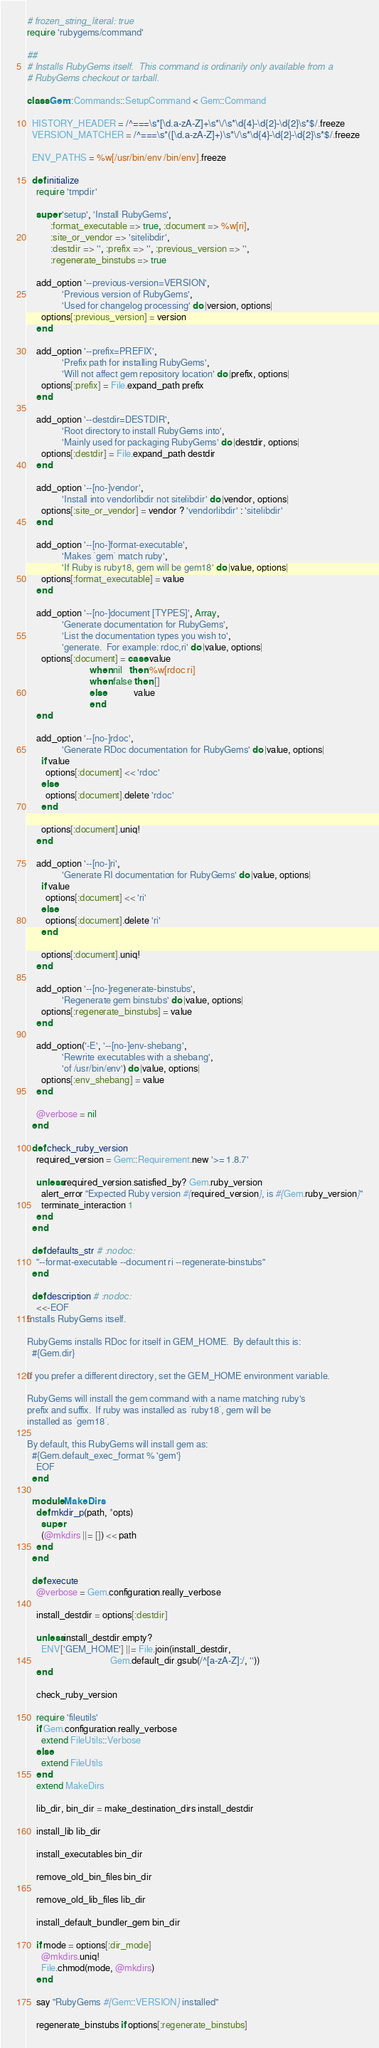<code> <loc_0><loc_0><loc_500><loc_500><_Ruby_># frozen_string_literal: true
require 'rubygems/command'

##
# Installs RubyGems itself.  This command is ordinarily only available from a
# RubyGems checkout or tarball.

class Gem::Commands::SetupCommand < Gem::Command

  HISTORY_HEADER = /^===\s*[\d.a-zA-Z]+\s*\/\s*\d{4}-\d{2}-\d{2}\s*$/.freeze
  VERSION_MATCHER = /^===\s*([\d.a-zA-Z]+)\s*\/\s*\d{4}-\d{2}-\d{2}\s*$/.freeze

  ENV_PATHS = %w[/usr/bin/env /bin/env].freeze

  def initialize
    require 'tmpdir'

    super 'setup', 'Install RubyGems',
          :format_executable => true, :document => %w[ri],
          :site_or_vendor => 'sitelibdir',
          :destdir => '', :prefix => '', :previous_version => '',
          :regenerate_binstubs => true

    add_option '--previous-version=VERSION',
               'Previous version of RubyGems',
               'Used for changelog processing' do |version, options|
      options[:previous_version] = version
    end

    add_option '--prefix=PREFIX',
               'Prefix path for installing RubyGems',
               'Will not affect gem repository location' do |prefix, options|
      options[:prefix] = File.expand_path prefix
    end

    add_option '--destdir=DESTDIR',
               'Root directory to install RubyGems into',
               'Mainly used for packaging RubyGems' do |destdir, options|
      options[:destdir] = File.expand_path destdir
    end

    add_option '--[no-]vendor',
               'Install into vendorlibdir not sitelibdir' do |vendor, options|
      options[:site_or_vendor] = vendor ? 'vendorlibdir' : 'sitelibdir'
    end

    add_option '--[no-]format-executable',
               'Makes `gem` match ruby',
               'If Ruby is ruby18, gem will be gem18' do |value, options|
      options[:format_executable] = value
    end

    add_option '--[no-]document [TYPES]', Array,
               'Generate documentation for RubyGems',
               'List the documentation types you wish to',
               'generate.  For example: rdoc,ri' do |value, options|
      options[:document] = case value
                           when nil   then %w[rdoc ri]
                           when false then []
                           else            value
                           end
    end

    add_option '--[no-]rdoc',
               'Generate RDoc documentation for RubyGems' do |value, options|
      if value
        options[:document] << 'rdoc'
      else
        options[:document].delete 'rdoc'
      end

      options[:document].uniq!
    end

    add_option '--[no-]ri',
               'Generate RI documentation for RubyGems' do |value, options|
      if value
        options[:document] << 'ri'
      else
        options[:document].delete 'ri'
      end

      options[:document].uniq!
    end

    add_option '--[no-]regenerate-binstubs',
               'Regenerate gem binstubs' do |value, options|
      options[:regenerate_binstubs] = value
    end

    add_option('-E', '--[no-]env-shebang',
               'Rewrite executables with a shebang',
               'of /usr/bin/env') do |value, options|
      options[:env_shebang] = value
    end

    @verbose = nil
  end

  def check_ruby_version
    required_version = Gem::Requirement.new '>= 1.8.7'

    unless required_version.satisfied_by? Gem.ruby_version
      alert_error "Expected Ruby version #{required_version}, is #{Gem.ruby_version}"
      terminate_interaction 1
    end
  end

  def defaults_str # :nodoc:
    "--format-executable --document ri --regenerate-binstubs"
  end

  def description # :nodoc:
    <<-EOF
Installs RubyGems itself.

RubyGems installs RDoc for itself in GEM_HOME.  By default this is:
  #{Gem.dir}

If you prefer a different directory, set the GEM_HOME environment variable.

RubyGems will install the gem command with a name matching ruby's
prefix and suffix.  If ruby was installed as `ruby18`, gem will be
installed as `gem18`.

By default, this RubyGems will install gem as:
  #{Gem.default_exec_format % 'gem'}
    EOF
  end

  module MakeDirs
    def mkdir_p(path, *opts)
      super
      (@mkdirs ||= []) << path
    end
  end

  def execute
    @verbose = Gem.configuration.really_verbose

    install_destdir = options[:destdir]

    unless install_destdir.empty?
      ENV['GEM_HOME'] ||= File.join(install_destdir,
                                    Gem.default_dir.gsub(/^[a-zA-Z]:/, ''))
    end

    check_ruby_version

    require 'fileutils'
    if Gem.configuration.really_verbose
      extend FileUtils::Verbose
    else
      extend FileUtils
    end
    extend MakeDirs

    lib_dir, bin_dir = make_destination_dirs install_destdir

    install_lib lib_dir

    install_executables bin_dir

    remove_old_bin_files bin_dir

    remove_old_lib_files lib_dir

    install_default_bundler_gem bin_dir

    if mode = options[:dir_mode]
      @mkdirs.uniq!
      File.chmod(mode, @mkdirs)
    end

    say "RubyGems #{Gem::VERSION} installed"

    regenerate_binstubs if options[:regenerate_binstubs]
</code> 